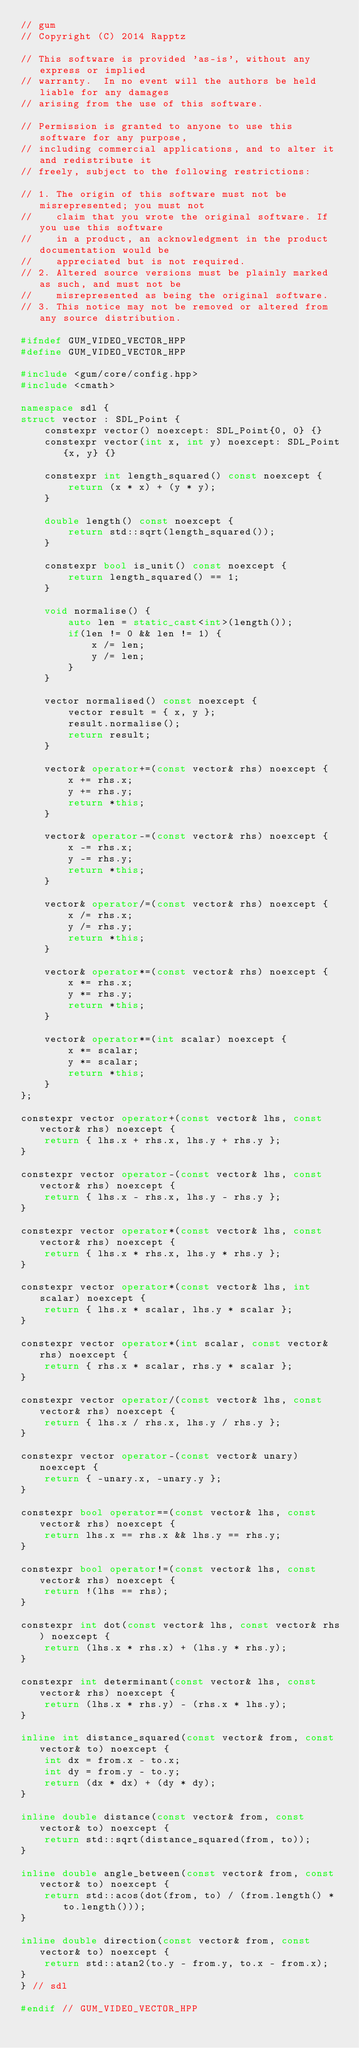<code> <loc_0><loc_0><loc_500><loc_500><_C++_>// gum
// Copyright (C) 2014 Rapptz

// This software is provided 'as-is', without any express or implied
// warranty.  In no event will the authors be held liable for any damages
// arising from the use of this software.

// Permission is granted to anyone to use this software for any purpose,
// including commercial applications, and to alter it and redistribute it
// freely, subject to the following restrictions:

// 1. The origin of this software must not be misrepresented; you must not
//    claim that you wrote the original software. If you use this software
//    in a product, an acknowledgment in the product documentation would be
//    appreciated but is not required.
// 2. Altered source versions must be plainly marked as such, and must not be
//    misrepresented as being the original software.
// 3. This notice may not be removed or altered from any source distribution.

#ifndef GUM_VIDEO_VECTOR_HPP
#define GUM_VIDEO_VECTOR_HPP

#include <gum/core/config.hpp>
#include <cmath>

namespace sdl {
struct vector : SDL_Point {
    constexpr vector() noexcept: SDL_Point{0, 0} {}
    constexpr vector(int x, int y) noexcept: SDL_Point{x, y} {}

    constexpr int length_squared() const noexcept {
        return (x * x) + (y * y);
    }

    double length() const noexcept {
        return std::sqrt(length_squared());
    }

    constexpr bool is_unit() const noexcept {
        return length_squared() == 1;
    }

    void normalise() {
        auto len = static_cast<int>(length());
        if(len != 0 && len != 1) {
            x /= len;
            y /= len;
        }
    }

    vector normalised() const noexcept {
        vector result = { x, y };
        result.normalise();
        return result;
    }

    vector& operator+=(const vector& rhs) noexcept {
        x += rhs.x;
        y += rhs.y;
        return *this;
    }

    vector& operator-=(const vector& rhs) noexcept {
        x -= rhs.x;
        y -= rhs.y;
        return *this;
    }

    vector& operator/=(const vector& rhs) noexcept {
        x /= rhs.x;
        y /= rhs.y;
        return *this;
    }

    vector& operator*=(const vector& rhs) noexcept {
        x *= rhs.x;
        y *= rhs.y;
        return *this;
    }

    vector& operator*=(int scalar) noexcept {
        x *= scalar;
        y *= scalar;
        return *this;
    }
};

constexpr vector operator+(const vector& lhs, const vector& rhs) noexcept {
    return { lhs.x + rhs.x, lhs.y + rhs.y };
}

constexpr vector operator-(const vector& lhs, const vector& rhs) noexcept {
    return { lhs.x - rhs.x, lhs.y - rhs.y };
}

constexpr vector operator*(const vector& lhs, const vector& rhs) noexcept {
    return { lhs.x * rhs.x, lhs.y * rhs.y };
}

constexpr vector operator*(const vector& lhs, int scalar) noexcept {
    return { lhs.x * scalar, lhs.y * scalar };
}

constexpr vector operator*(int scalar, const vector& rhs) noexcept {
    return { rhs.x * scalar, rhs.y * scalar };
}

constexpr vector operator/(const vector& lhs, const vector& rhs) noexcept {
    return { lhs.x / rhs.x, lhs.y / rhs.y };
}

constexpr vector operator-(const vector& unary) noexcept {
    return { -unary.x, -unary.y };
}

constexpr bool operator==(const vector& lhs, const vector& rhs) noexcept {
    return lhs.x == rhs.x && lhs.y == rhs.y;
}

constexpr bool operator!=(const vector& lhs, const vector& rhs) noexcept {
    return !(lhs == rhs);
}

constexpr int dot(const vector& lhs, const vector& rhs) noexcept {
    return (lhs.x * rhs.x) + (lhs.y * rhs.y);
}

constexpr int determinant(const vector& lhs, const vector& rhs) noexcept {
    return (lhs.x * rhs.y) - (rhs.x * lhs.y);
}

inline int distance_squared(const vector& from, const vector& to) noexcept {
    int dx = from.x - to.x;
    int dy = from.y - to.y;
    return (dx * dx) + (dy * dy);
}

inline double distance(const vector& from, const vector& to) noexcept {
    return std::sqrt(distance_squared(from, to));
}

inline double angle_between(const vector& from, const vector& to) noexcept {
    return std::acos(dot(from, to) / (from.length() * to.length()));
}

inline double direction(const vector& from, const vector& to) noexcept {
    return std::atan2(to.y - from.y, to.x - from.x);
}
} // sdl

#endif // GUM_VIDEO_VECTOR_HPP
</code> 